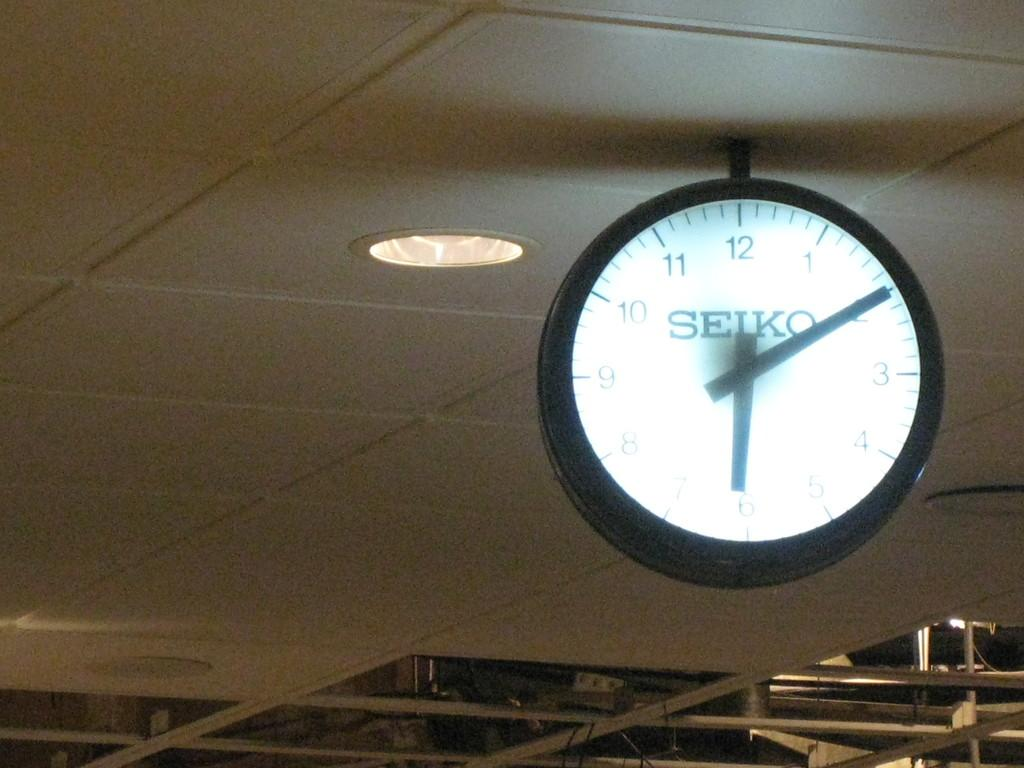<image>
Present a compact description of the photo's key features. The Seiko clock hanging from the ceiling indicates it is ten minutes past six. 